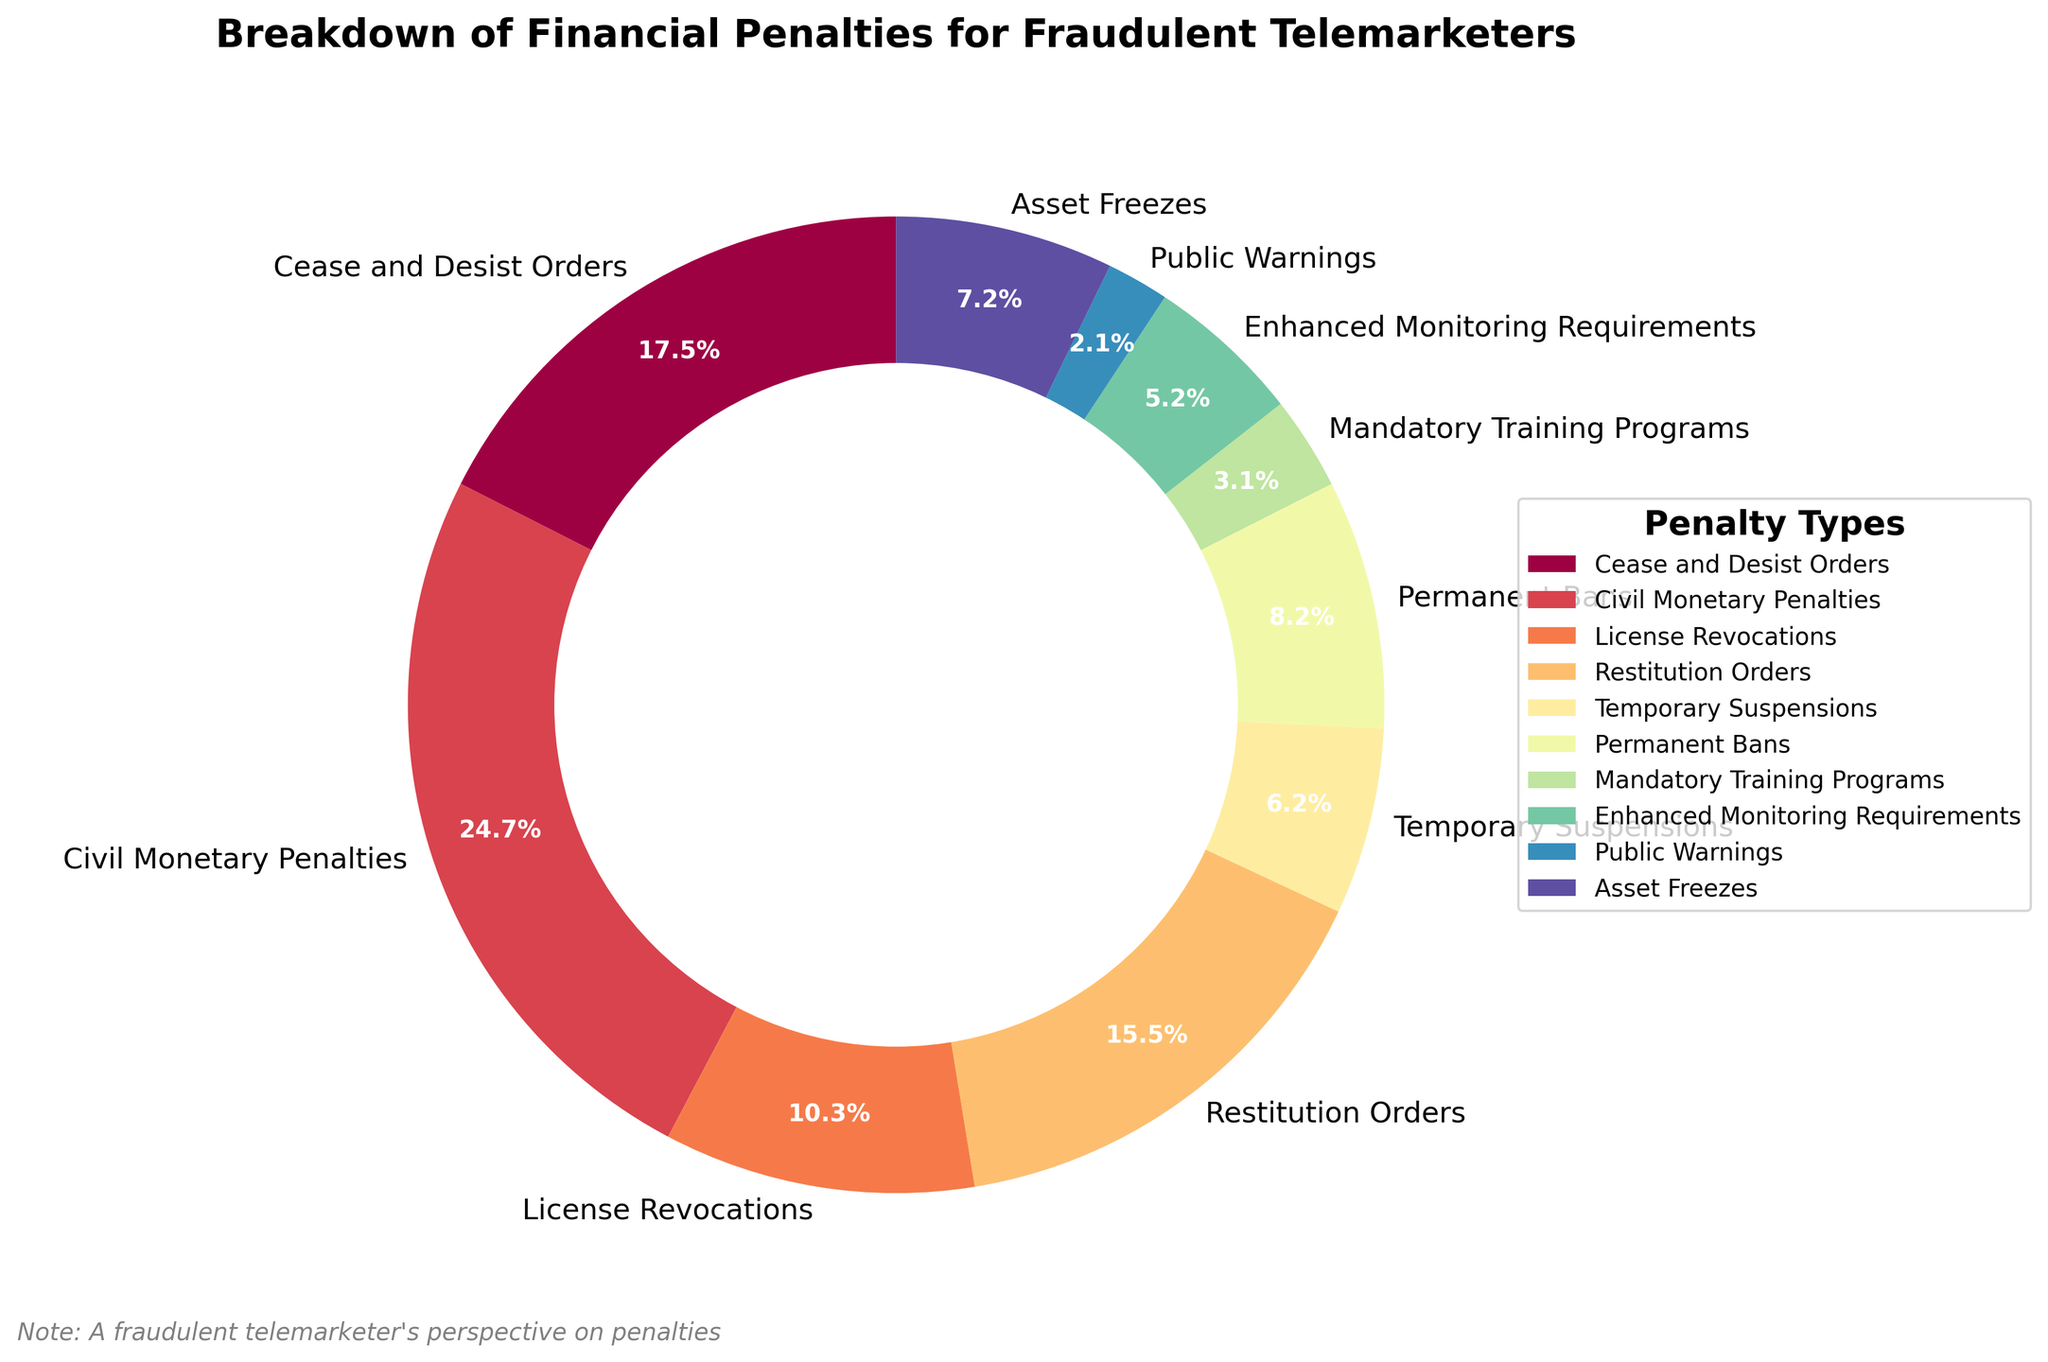What is the most common type of financial penalty imposed on fraudulent telemarketers? The largest section of the pie chart represents the most common type of penalty. The section labeled "Civil Monetary Penalties" has the largest percentage.
Answer: Civil Monetary Penalties Which penalty type constitutes the smallest percentage of the financial penalties? The smallest slice of the pie chart represents the least common financial penalty. The section labeled "Public Warnings" constitutes the smallest percentage.
Answer: Public Warnings What is the combined percentage of "Cease and Desist Orders" and "Civil Monetary Penalties"? Add the percentages of the slices labeled "Cease and Desist Orders" and "Civil Monetary Penalties". "Cease and Desist Orders" is 26.9% and "Civil Monetary Penalties" is 37.9%. Adding these gives 26.9% + 37.9% = 64.8%.
Answer: 64.8% How does the percentage of "License Revocations" compare to "Permanent Bans"? The pie chart slices for "License Revocations" and "Permanent Bans" need to be compared. "License Revocations" is 15.8% and "Permanent Bans" is 12.6%. Therefore, "License Revocations" has a higher percentage than "Permanent Bans".
Answer: License Revocations has a higher percentage If we added the percentages of penalties related to suspensions ("Temporary Suspensions" and "Permanent Bans"), what is the resulting percentage? Sum the percentages of "Temporary Suspensions" and "Permanent Bans" slices. "Temporary Suspensions" is 9.5% and "Permanent Bans" is 12.6%. Adding these gives 9.5% + 12.6% = 22.1%.
Answer: 22.1% What visual features are used in the pie chart to highlight the differences between penalty types? The pie chart uses different colors and sizes of the slices, percentage labels on each slice, and the legend to help differentiate between penalty types. Each slice is colored with a unique shade and annotated with the percentage of the total penalties it represents.
Answer: Different colors, sizes, percentage labels, and legend 